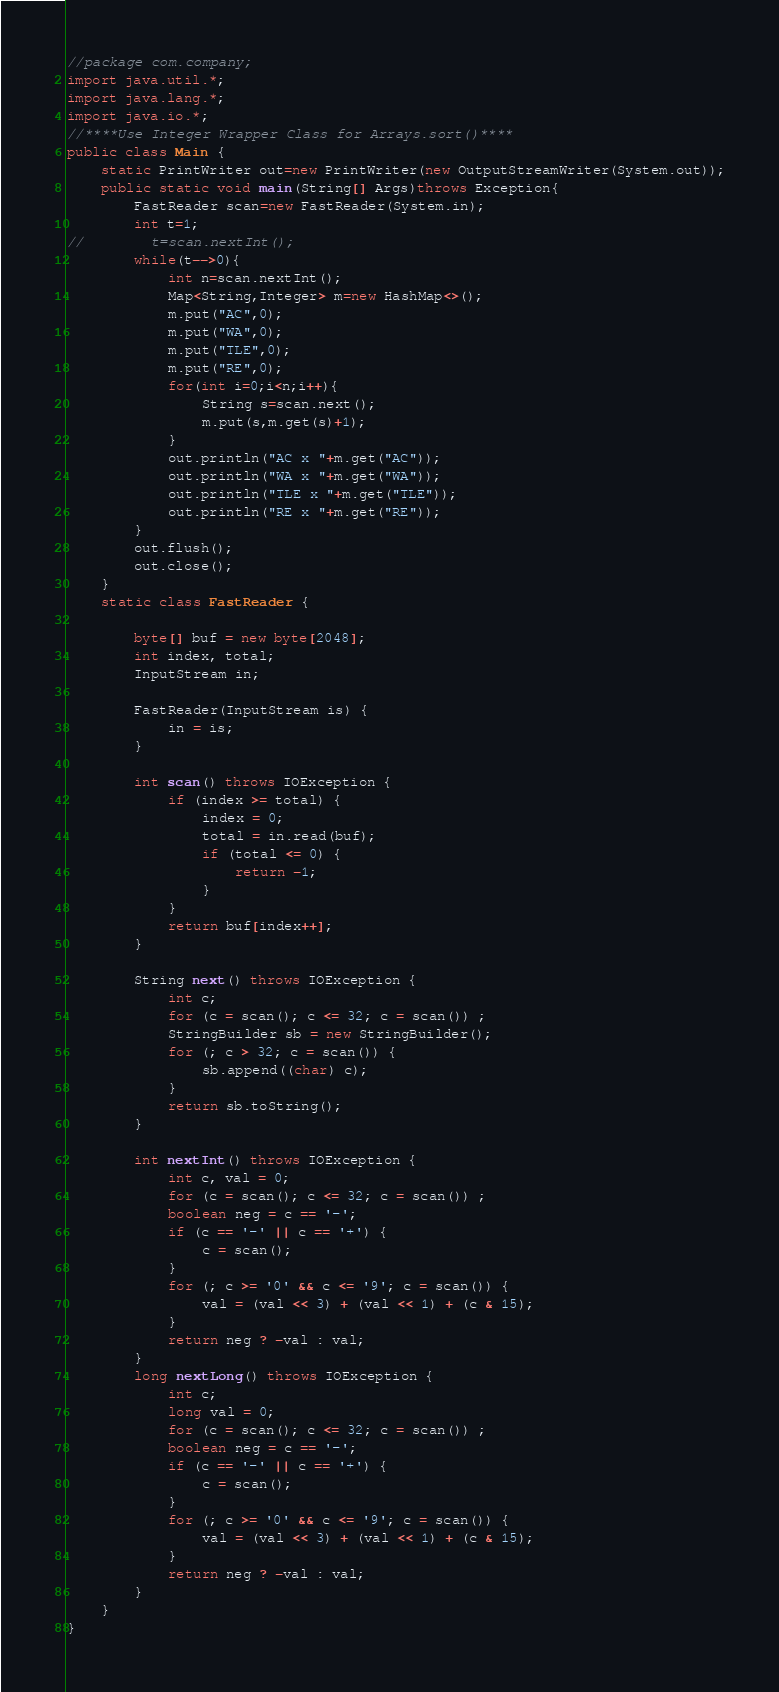Convert code to text. <code><loc_0><loc_0><loc_500><loc_500><_Java_>//package com.company;
import java.util.*;
import java.lang.*;
import java.io.*;
//****Use Integer Wrapper Class for Arrays.sort()****
public class Main {
    static PrintWriter out=new PrintWriter(new OutputStreamWriter(System.out));
    public static void main(String[] Args)throws Exception{
        FastReader scan=new FastReader(System.in);
        int t=1;
//        t=scan.nextInt();
        while(t-->0){
            int n=scan.nextInt();
            Map<String,Integer> m=new HashMap<>();
            m.put("AC",0);
            m.put("WA",0);
            m.put("TLE",0);
            m.put("RE",0);
            for(int i=0;i<n;i++){
                String s=scan.next();
                m.put(s,m.get(s)+1);
            }
            out.println("AC x "+m.get("AC"));
            out.println("WA x "+m.get("WA"));
            out.println("TLE x "+m.get("TLE"));
            out.println("RE x "+m.get("RE"));
        }
        out.flush();
        out.close();
    }
    static class FastReader {

        byte[] buf = new byte[2048];
        int index, total;
        InputStream in;

        FastReader(InputStream is) {
            in = is;
        }

        int scan() throws IOException {
            if (index >= total) {
                index = 0;
                total = in.read(buf);
                if (total <= 0) {
                    return -1;
                }
            }
            return buf[index++];
        }

        String next() throws IOException {
            int c;
            for (c = scan(); c <= 32; c = scan()) ;
            StringBuilder sb = new StringBuilder();
            for (; c > 32; c = scan()) {
                sb.append((char) c);
            }
            return sb.toString();
        }

        int nextInt() throws IOException {
            int c, val = 0;
            for (c = scan(); c <= 32; c = scan()) ;
            boolean neg = c == '-';
            if (c == '-' || c == '+') {
                c = scan();
            }
            for (; c >= '0' && c <= '9'; c = scan()) {
                val = (val << 3) + (val << 1) + (c & 15);
            }
            return neg ? -val : val;
        }
        long nextLong() throws IOException {
            int c;
            long val = 0;
            for (c = scan(); c <= 32; c = scan()) ;
            boolean neg = c == '-';
            if (c == '-' || c == '+') {
                c = scan();
            }
            for (; c >= '0' && c <= '9'; c = scan()) {
                val = (val << 3) + (val << 1) + (c & 15);
            }
            return neg ? -val : val;
        }
    }
}
</code> 